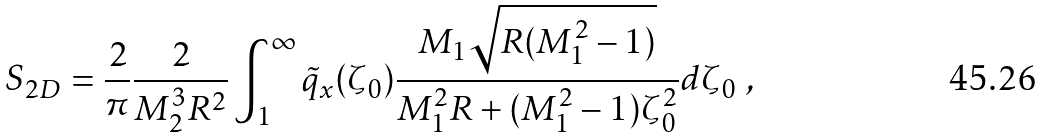<formula> <loc_0><loc_0><loc_500><loc_500>S _ { 2 D } = \frac { 2 } { \pi } \frac { 2 } { M _ { 2 } ^ { 3 } R ^ { 2 } } \int _ { 1 } ^ { \infty } \tilde { q } _ { x } ( \zeta _ { 0 } ) \frac { M _ { 1 } \sqrt { R ( M _ { 1 } ^ { 2 } - 1 ) } } { M _ { 1 } ^ { 2 } R + ( M _ { 1 } ^ { 2 } - 1 ) \zeta _ { 0 } ^ { 2 } } d \zeta _ { 0 } \ ,</formula> 